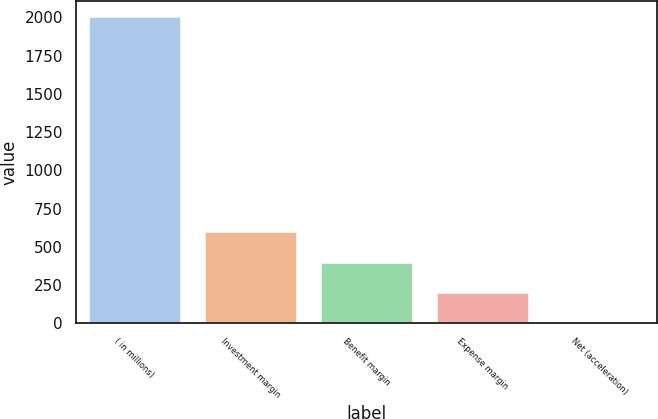Convert chart. <chart><loc_0><loc_0><loc_500><loc_500><bar_chart><fcel>( in millions)<fcel>Investment margin<fcel>Benefit margin<fcel>Expense margin<fcel>Net (acceleration)<nl><fcel>2006<fcel>603.2<fcel>402.8<fcel>202.4<fcel>2<nl></chart> 